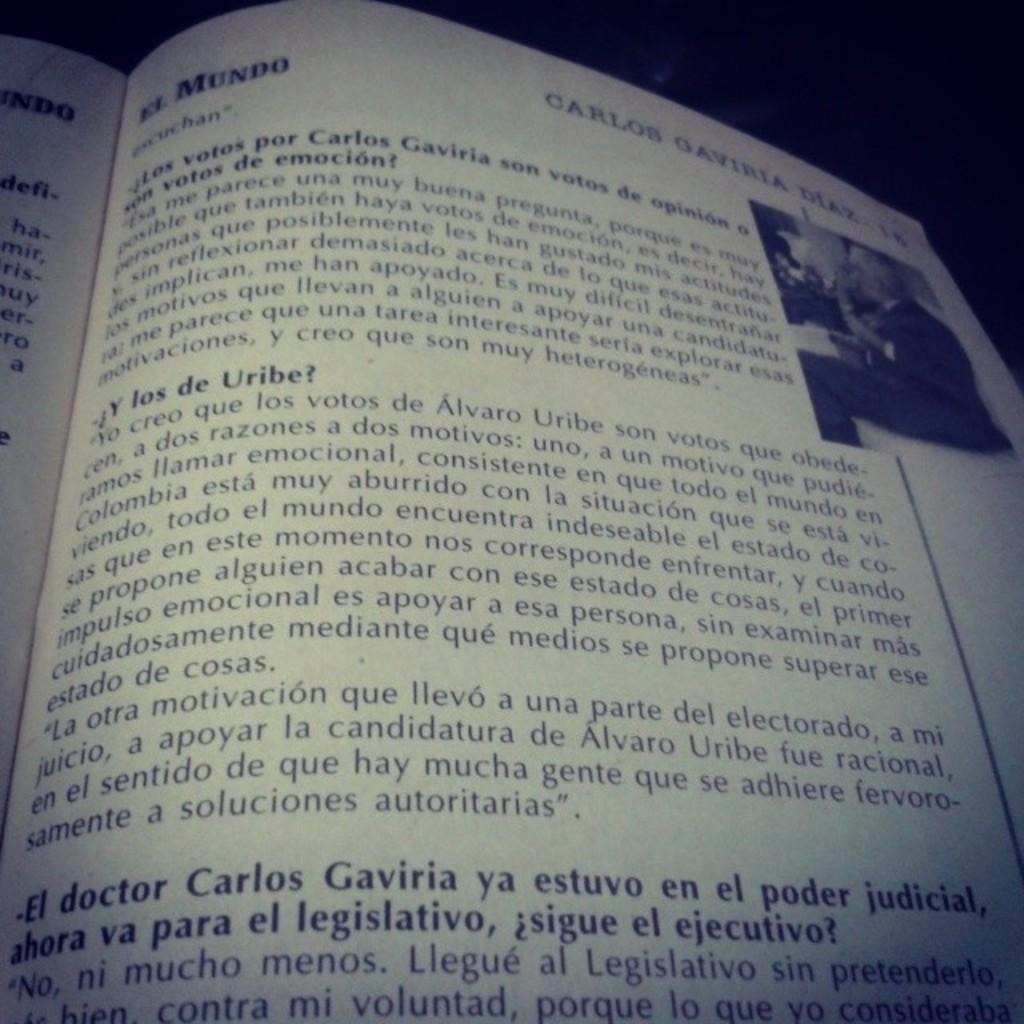How many pages are visible in the image? There are 2 pages in the image. What can be found on the pages? Words are written on the pages. Is there any visual element besides text in the image? Yes, there is a picture in the image. Can you describe any specific lines or shapes in the image? There is a straight line in the image. What is the color of the background in the image? The background of the image is dark. Is there an expert holding a bone in the image? There is no expert or bone present in the image. What type of test is being conducted in the image? There is no test being conducted in the image; it features 2 pages with words and a picture. 